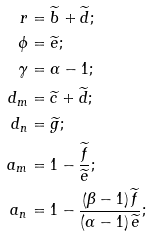Convert formula to latex. <formula><loc_0><loc_0><loc_500><loc_500>r & = \widetilde { b } + \widetilde { d } ; \\ \phi & = \widetilde { e } ; \\ \gamma & = \alpha - 1 ; \\ d _ { m } & = \widetilde { c } + \widetilde { d } ; \\ d _ { n } & = \widetilde { g } ; \\ a _ { m } & = 1 - \frac { \widetilde { f } } { \widetilde { e } } ; \\ a _ { n } & = 1 - \frac { \left ( \beta - 1 \right ) \widetilde { f } } { \left ( \alpha - 1 \right ) \widetilde { e } } ;</formula> 